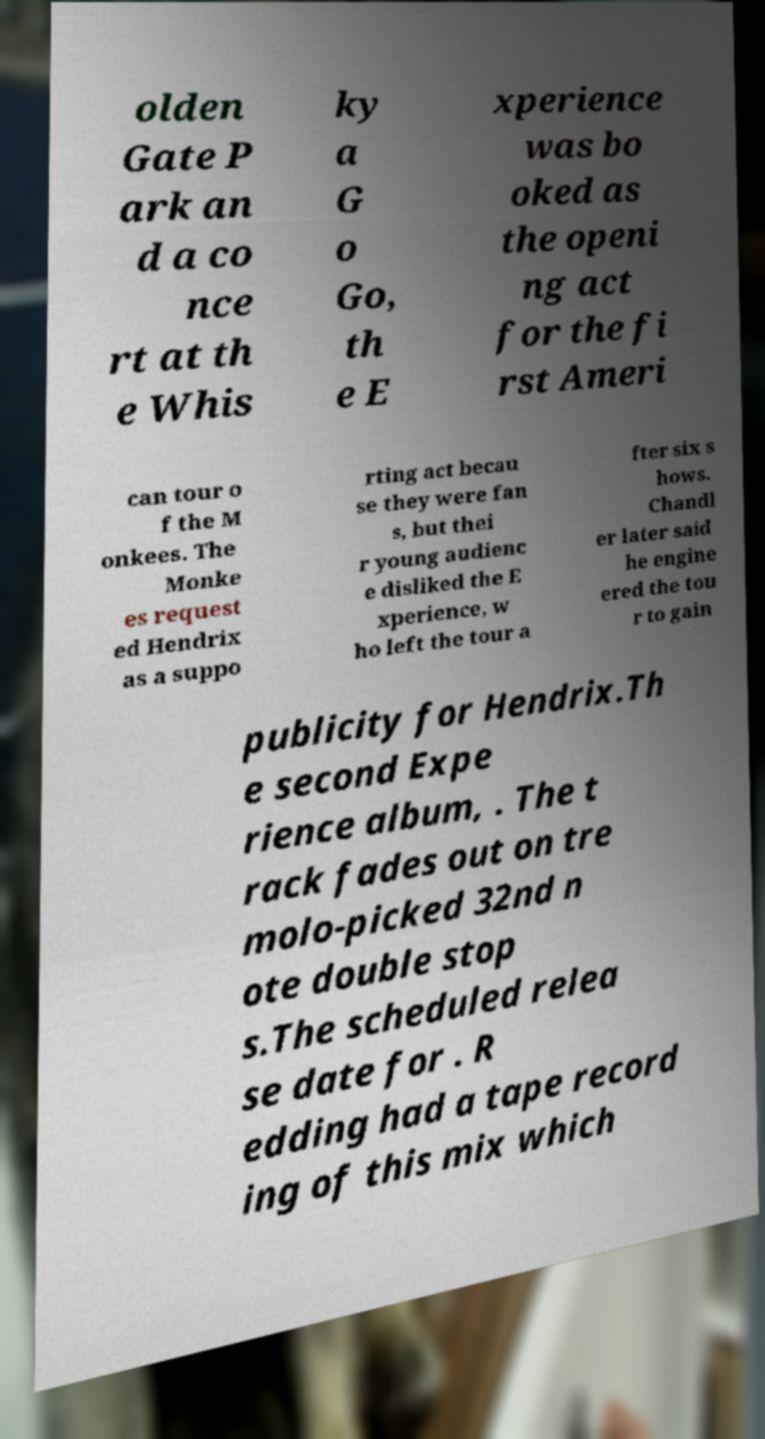Could you extract and type out the text from this image? olden Gate P ark an d a co nce rt at th e Whis ky a G o Go, th e E xperience was bo oked as the openi ng act for the fi rst Ameri can tour o f the M onkees. The Monke es request ed Hendrix as a suppo rting act becau se they were fan s, but thei r young audienc e disliked the E xperience, w ho left the tour a fter six s hows. Chandl er later said he engine ered the tou r to gain publicity for Hendrix.Th e second Expe rience album, . The t rack fades out on tre molo-picked 32nd n ote double stop s.The scheduled relea se date for . R edding had a tape record ing of this mix which 